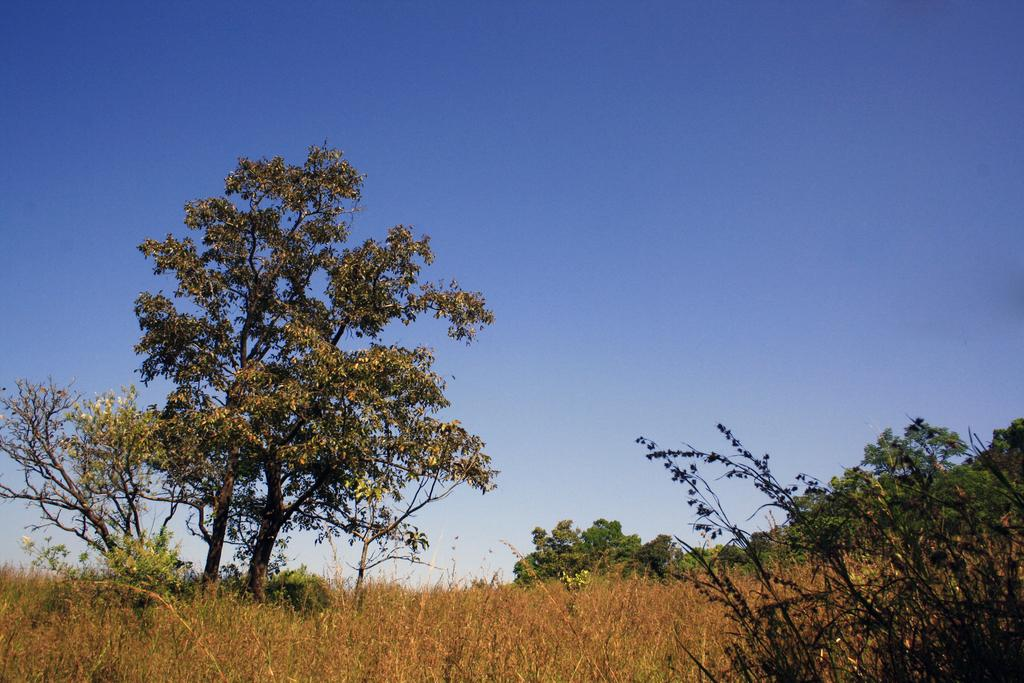What type of vegetation can be seen in the image? There are trees in the image. What part of the natural environment is visible in the image? The sky is visible in the background of the image. What type of tent is set up near the church in the image? There is no tent or church present in the image; it only features trees and the sky. 